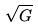<formula> <loc_0><loc_0><loc_500><loc_500>\sqrt { G }</formula> 